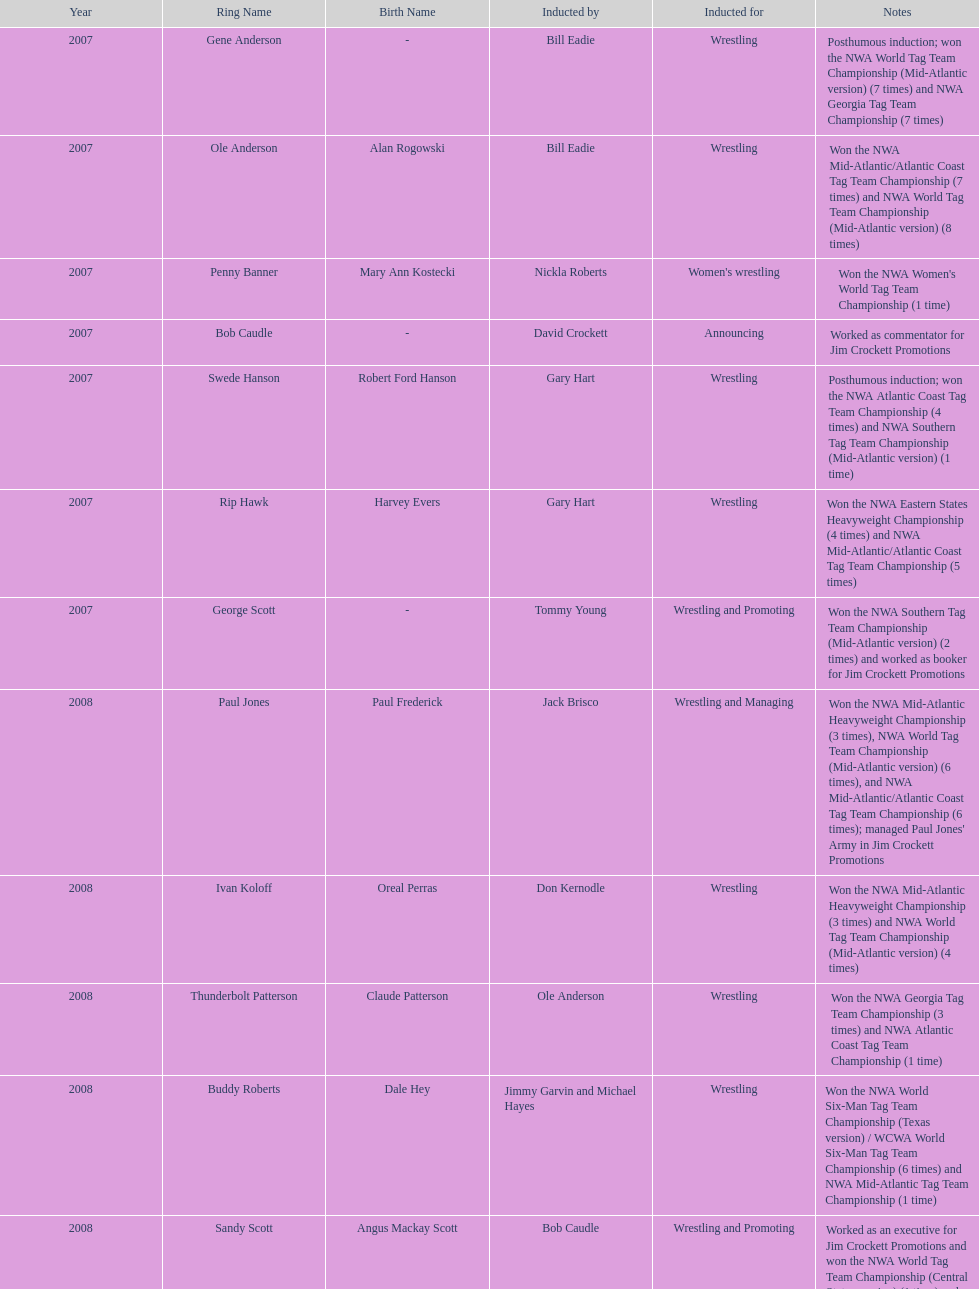Who won the most nwa southern tag team championships (mid-america version)? Jackie Fargo. 